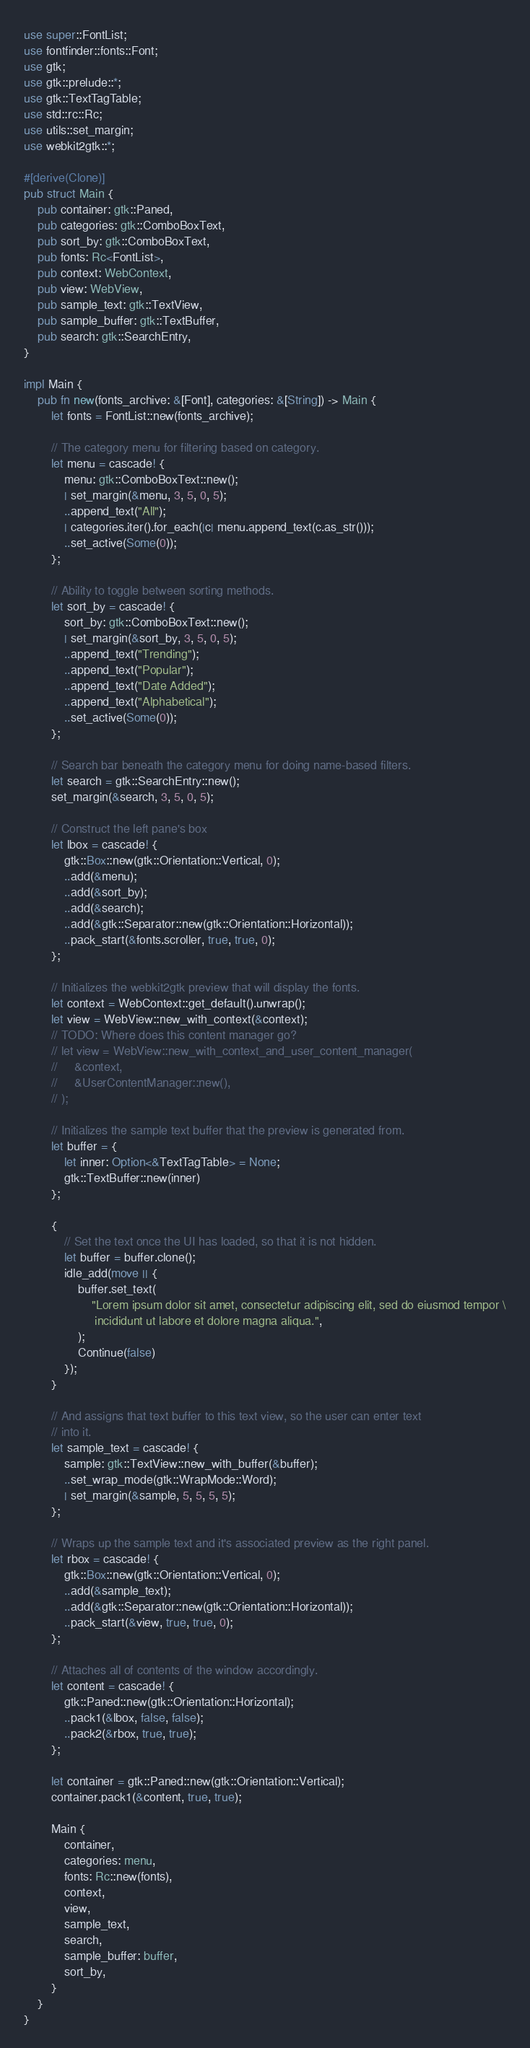Convert code to text. <code><loc_0><loc_0><loc_500><loc_500><_Rust_>use super::FontList;
use fontfinder::fonts::Font;
use gtk;
use gtk::prelude::*;
use gtk::TextTagTable;
use std::rc::Rc;
use utils::set_margin;
use webkit2gtk::*;

#[derive(Clone)]
pub struct Main {
    pub container: gtk::Paned,
    pub categories: gtk::ComboBoxText,
    pub sort_by: gtk::ComboBoxText,
    pub fonts: Rc<FontList>,
    pub context: WebContext,
    pub view: WebView,
    pub sample_text: gtk::TextView,
    pub sample_buffer: gtk::TextBuffer,
    pub search: gtk::SearchEntry,
}

impl Main {
    pub fn new(fonts_archive: &[Font], categories: &[String]) -> Main {
        let fonts = FontList::new(fonts_archive);

        // The category menu for filtering based on category.
        let menu = cascade! {
            menu: gtk::ComboBoxText::new();
            | set_margin(&menu, 3, 5, 0, 5);
            ..append_text("All");
            | categories.iter().for_each(|c| menu.append_text(c.as_str()));
            ..set_active(Some(0));
        };

        // Ability to toggle between sorting methods.
        let sort_by = cascade! {
            sort_by: gtk::ComboBoxText::new();
            | set_margin(&sort_by, 3, 5, 0, 5);
            ..append_text("Trending");
            ..append_text("Popular");
            ..append_text("Date Added");
            ..append_text("Alphabetical");
            ..set_active(Some(0));
        };

        // Search bar beneath the category menu for doing name-based filters.
        let search = gtk::SearchEntry::new();
        set_margin(&search, 3, 5, 0, 5);

        // Construct the left pane's box
        let lbox = cascade! {
            gtk::Box::new(gtk::Orientation::Vertical, 0);
            ..add(&menu);
            ..add(&sort_by);
            ..add(&search);
            ..add(&gtk::Separator::new(gtk::Orientation::Horizontal));
            ..pack_start(&fonts.scroller, true, true, 0);
        };

        // Initializes the webkit2gtk preview that will display the fonts.
        let context = WebContext::get_default().unwrap();
        let view = WebView::new_with_context(&context);
        // TODO: Where does this content manager go?
        // let view = WebView::new_with_context_and_user_content_manager(
        //     &context,
        //     &UserContentManager::new(),
        // );

        // Initializes the sample text buffer that the preview is generated from.
        let buffer = {
            let inner: Option<&TextTagTable> = None;
            gtk::TextBuffer::new(inner)
        };

        {
            // Set the text once the UI has loaded, so that it is not hidden.
            let buffer = buffer.clone();
            idle_add(move || {
                buffer.set_text(
                    "Lorem ipsum dolor sit amet, consectetur adipiscing elit, sed do eiusmod tempor \
                     incididunt ut labore et dolore magna aliqua.",
                );
                Continue(false)
            });
        }

        // And assigns that text buffer to this text view, so the user can enter text
        // into it.
        let sample_text = cascade! {
            sample: gtk::TextView::new_with_buffer(&buffer);
            ..set_wrap_mode(gtk::WrapMode::Word);
            | set_margin(&sample, 5, 5, 5, 5);
        };

        // Wraps up the sample text and it's associated preview as the right panel.
        let rbox = cascade! {
            gtk::Box::new(gtk::Orientation::Vertical, 0);
            ..add(&sample_text);
            ..add(&gtk::Separator::new(gtk::Orientation::Horizontal));
            ..pack_start(&view, true, true, 0);
        };

        // Attaches all of contents of the window accordingly.
        let content = cascade! {
            gtk::Paned::new(gtk::Orientation::Horizontal);
            ..pack1(&lbox, false, false);
            ..pack2(&rbox, true, true);
        };

        let container = gtk::Paned::new(gtk::Orientation::Vertical);
        container.pack1(&content, true, true);

        Main {
            container,
            categories: menu,
            fonts: Rc::new(fonts),
            context,
            view,
            sample_text,
            search,
            sample_buffer: buffer,
            sort_by,
        }
    }
}
</code> 